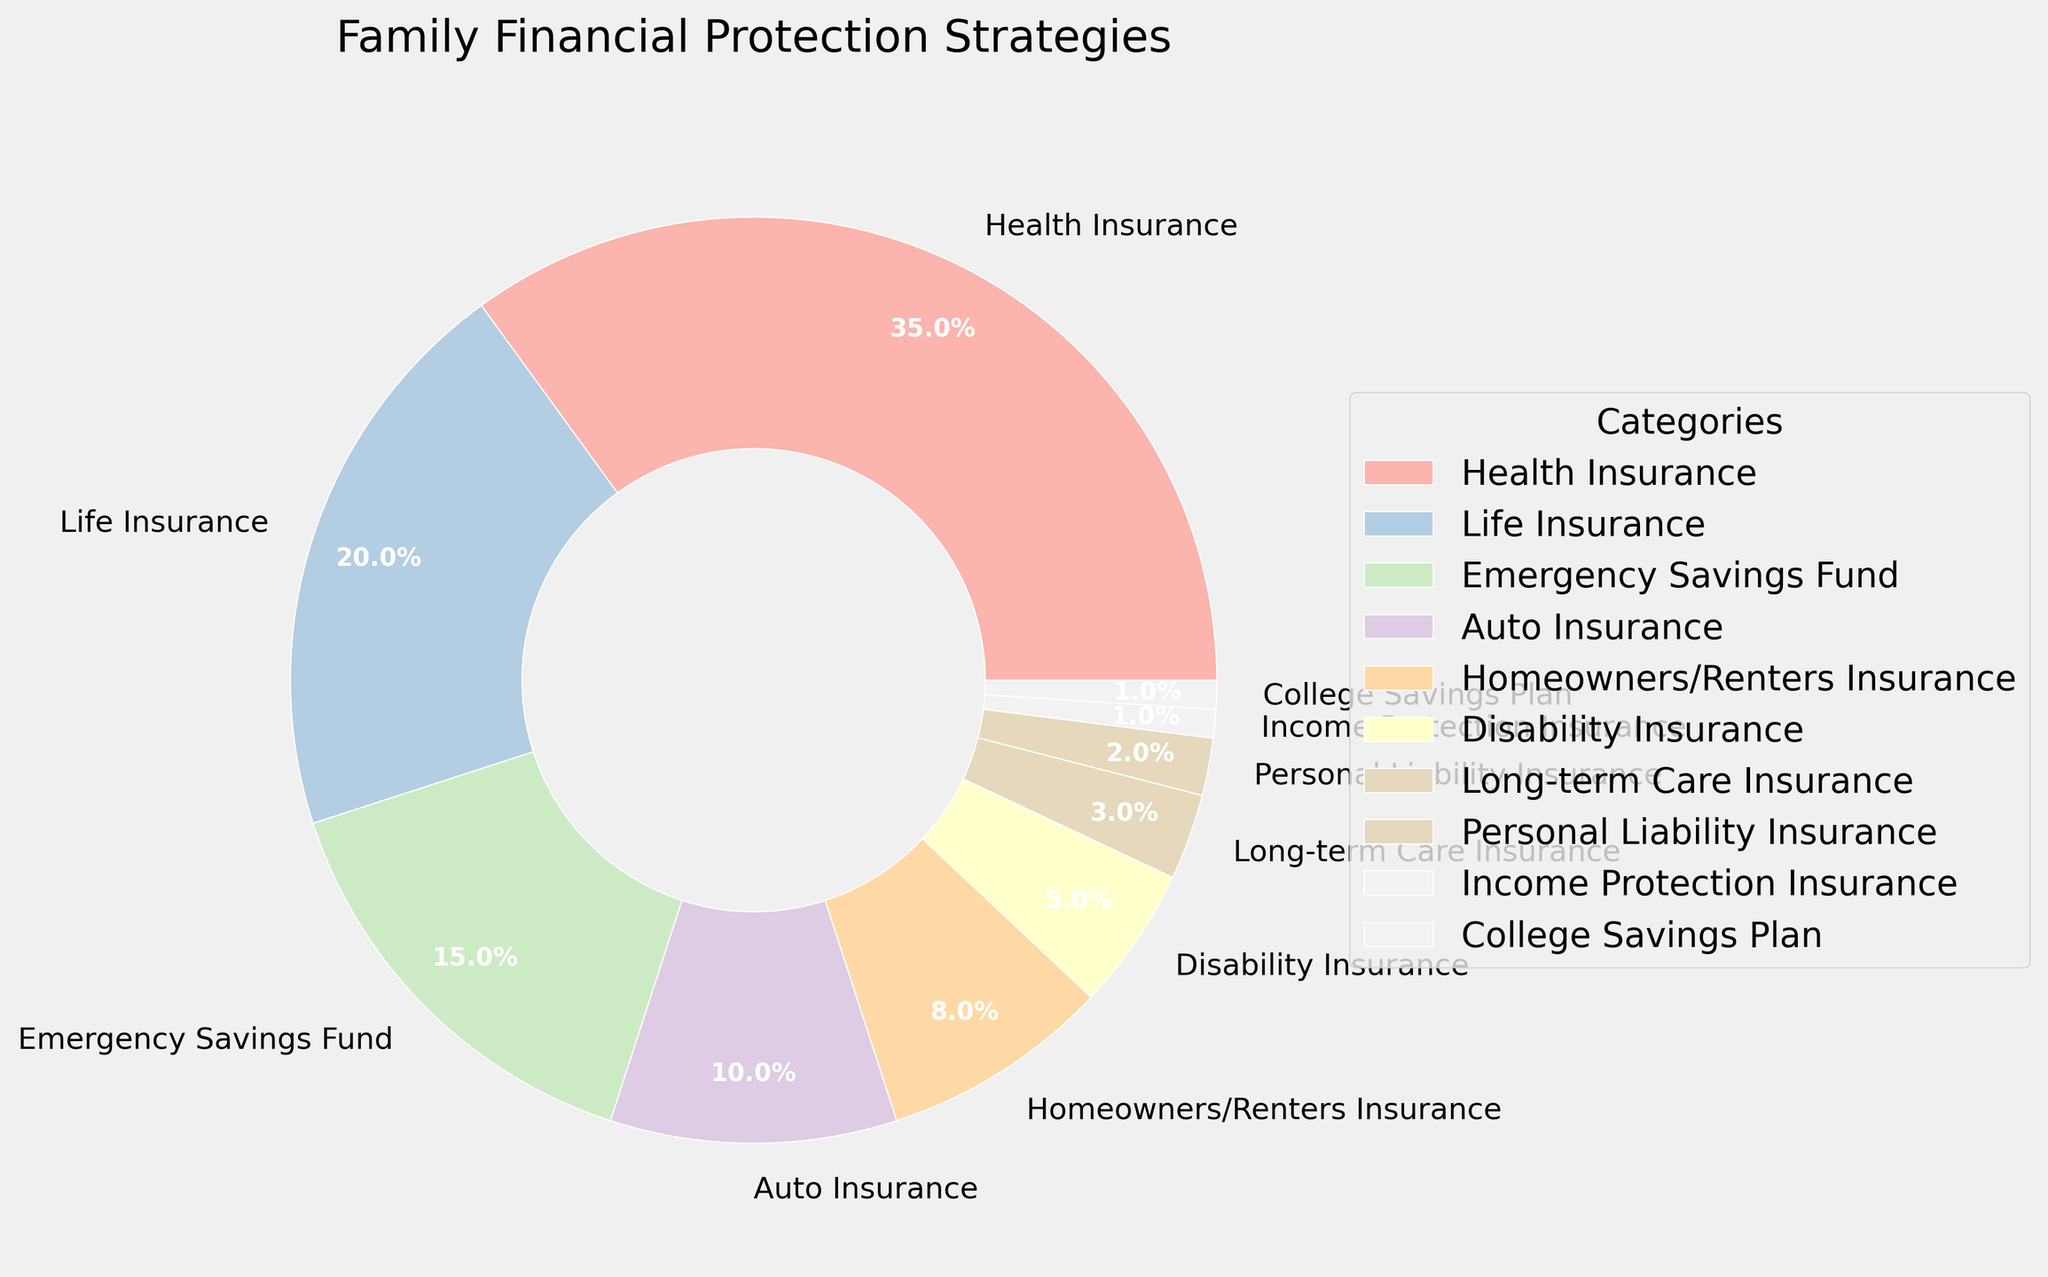what percentage of the family's financial protection strategies is health insurance? Look at the segment labeled "Health Insurance" in the pie chart; the percentage is written directly.
Answer: 35% compare the percentage of life insurance to auto insurance Refer to the pie chart: Life Insurance is labeled as 20%, and Auto Insurance is labeled as 10%.
Answer: Life Insurance is 10% more which category has the smallest percentage and what is it? Identify the smallest segment by its size and label in the pie chart. The smallest is "Income Protection Insurance" with 1%.
Answer: Income Protection Insurance, 1% what is the combined percentage of emergency savings fund and homeowners/renters insurance? Locate and add the labeled percentages of "Emergency Savings Fund" and "Homeowners/Renters Insurance" in the pie chart. 15% + 8% = 23%
Answer: 23% is the percentage of disability insurance greater than that of long-term care insurance? Compare the labeled percentages for "Disability Insurance" (5%) and "Long-term Care Insurance" (3%) in the pie chart.
Answer: Yes, Disability Insurance is greater what's the difference in percentage between auto insurance and college savings plan? Find the difference between the labeled percentages of "Auto Insurance" (10%) and "College Savings Plan" (1%). 10% - 1% = 9%
Answer: 9% are there more categories with a percentage greater than 10% or less than 10%? Count the categories labeled above 10% and those below 10% in the pie chart: >10% (Health Insurance, Life Insurance, Emergency Savings Fund) = 3, <10% = 7.
Answer: Less than 10% what is the sum of the top three categories by percentage? Identify and sum the top three labeled percentages: Health Insurance (35%), Life Insurance (20%), Emergency Savings Fund (15%). 35% + 20% + 15% = 70%
Answer: 70% what color represents personal liability insurance in the chart? Locate the segment labeled "Personal Liability Insurance" in the pie chart and observe its color.
Answer: Light pink (or similar pastel shade, depending on the colormap) how many categories make up less than 5% each? Count the segments labeled with percentages less than 5%: Long-term Care Insurance (3%), Personal Liability Insurance (2%), Income Protection Insurance (1%), College Savings Plan (1%).
Answer: 4 